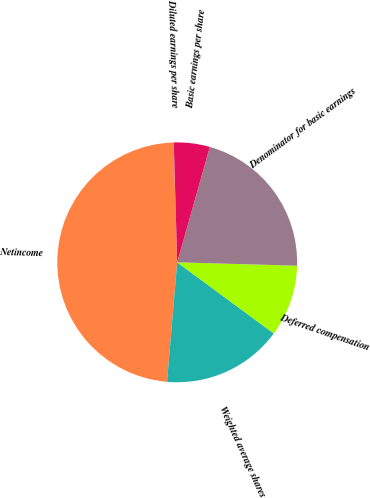<chart> <loc_0><loc_0><loc_500><loc_500><pie_chart><fcel>Netincome<fcel>Weighted average shares<fcel>Deferred compensation<fcel>Denominator for basic earnings<fcel>Basic earnings per share<fcel>Diluted earnings per share<nl><fcel>48.14%<fcel>16.25%<fcel>9.66%<fcel>21.06%<fcel>4.85%<fcel>0.04%<nl></chart> 